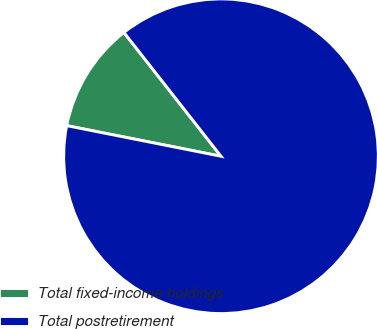Convert chart. <chart><loc_0><loc_0><loc_500><loc_500><pie_chart><fcel>Total fixed-income holdings<fcel>Total postretirement<nl><fcel>11.3%<fcel>88.7%<nl></chart> 